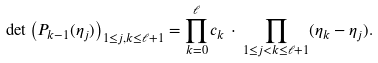<formula> <loc_0><loc_0><loc_500><loc_500>\det \left ( P _ { k - 1 } ( \eta _ { j } ) \right ) _ { 1 \leq j , k \leq \ell + 1 } = \prod _ { k = 0 } ^ { \ell } c _ { k } \, \cdot \, \prod _ { 1 \leq j < k \leq \ell + 1 } ( \eta _ { k } - \eta _ { j } ) .</formula> 